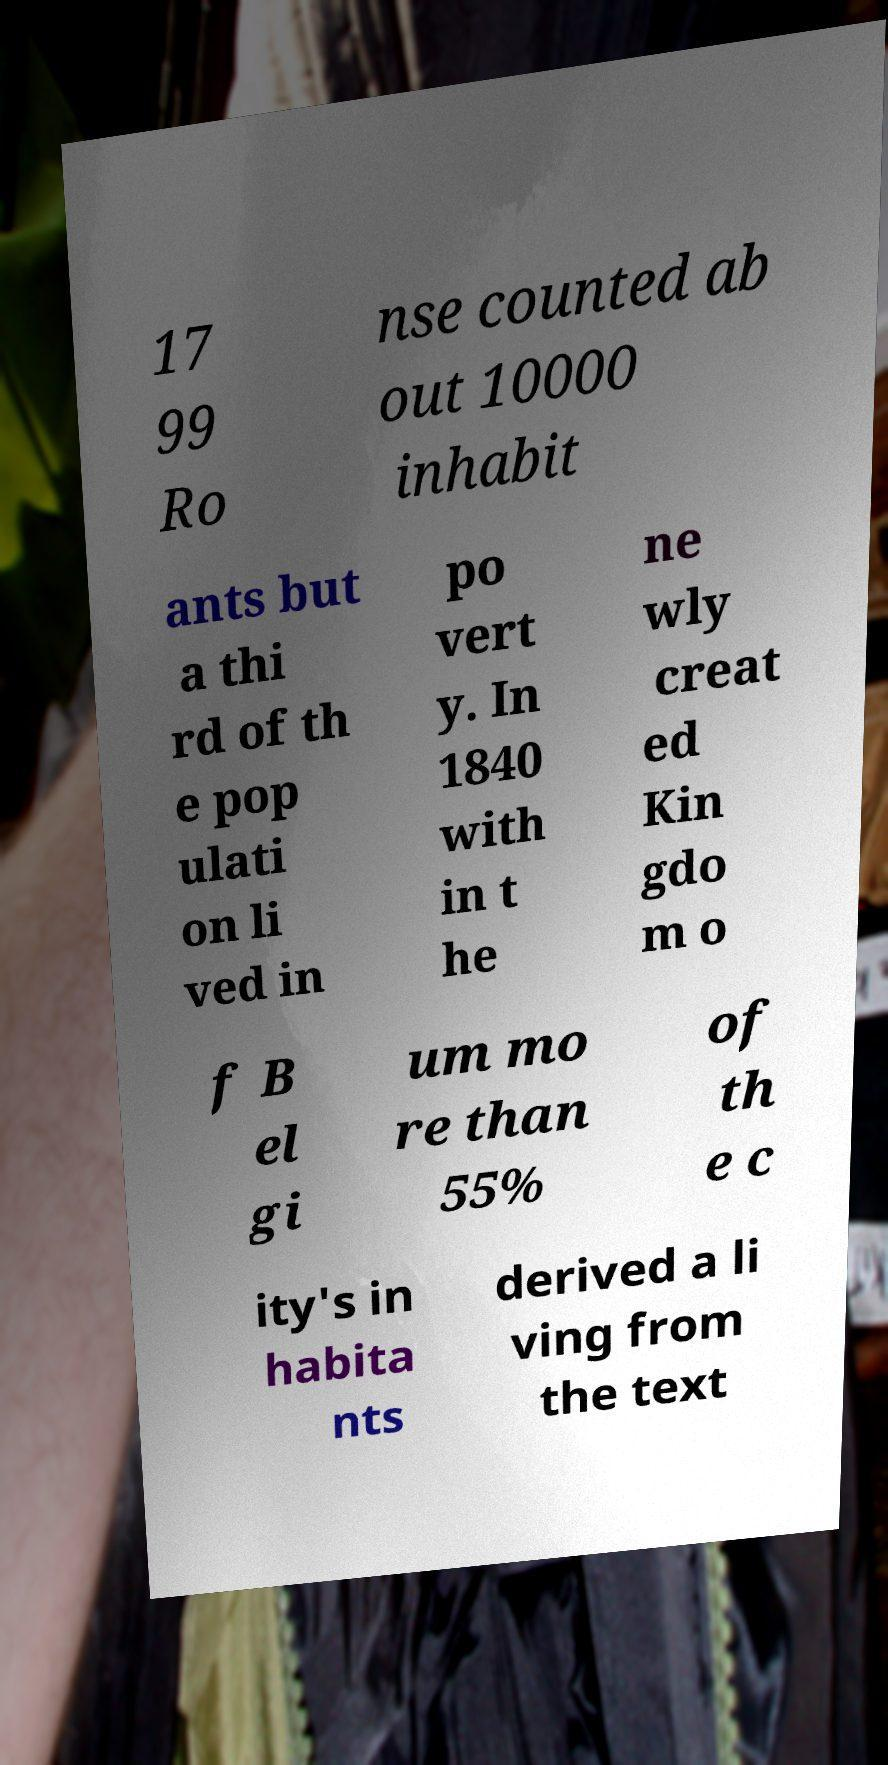Can you read and provide the text displayed in the image?This photo seems to have some interesting text. Can you extract and type it out for me? 17 99 Ro nse counted ab out 10000 inhabit ants but a thi rd of th e pop ulati on li ved in po vert y. In 1840 with in t he ne wly creat ed Kin gdo m o f B el gi um mo re than 55% of th e c ity's in habita nts derived a li ving from the text 